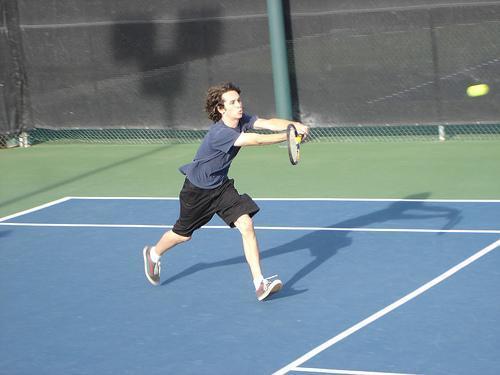How many people are in this picture?
Give a very brief answer. 1. 